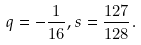<formula> <loc_0><loc_0><loc_500><loc_500>q = - \frac { 1 } { 1 6 } , s = \frac { 1 2 7 } { 1 2 8 } .</formula> 